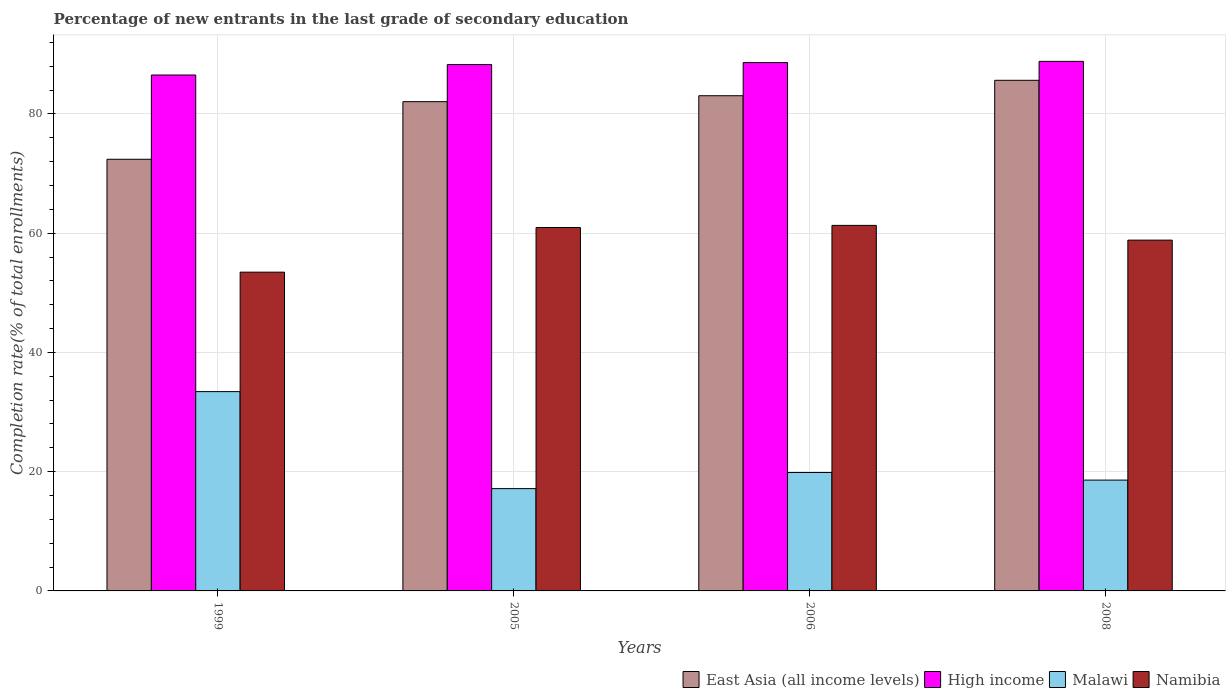How many groups of bars are there?
Provide a succinct answer. 4. How many bars are there on the 3rd tick from the left?
Offer a terse response. 4. How many bars are there on the 3rd tick from the right?
Give a very brief answer. 4. In how many cases, is the number of bars for a given year not equal to the number of legend labels?
Your response must be concise. 0. What is the percentage of new entrants in East Asia (all income levels) in 1999?
Offer a terse response. 72.4. Across all years, what is the maximum percentage of new entrants in Malawi?
Provide a short and direct response. 33.43. Across all years, what is the minimum percentage of new entrants in High income?
Give a very brief answer. 86.53. In which year was the percentage of new entrants in Namibia minimum?
Keep it short and to the point. 1999. What is the total percentage of new entrants in Malawi in the graph?
Offer a terse response. 89.04. What is the difference between the percentage of new entrants in High income in 2005 and that in 2008?
Provide a short and direct response. -0.54. What is the difference between the percentage of new entrants in High income in 2005 and the percentage of new entrants in Namibia in 2006?
Your response must be concise. 26.97. What is the average percentage of new entrants in Namibia per year?
Your answer should be very brief. 58.64. In the year 2005, what is the difference between the percentage of new entrants in Namibia and percentage of new entrants in East Asia (all income levels)?
Make the answer very short. -21.11. What is the ratio of the percentage of new entrants in Namibia in 2005 to that in 2008?
Your answer should be very brief. 1.04. Is the difference between the percentage of new entrants in Namibia in 1999 and 2006 greater than the difference between the percentage of new entrants in East Asia (all income levels) in 1999 and 2006?
Offer a very short reply. Yes. What is the difference between the highest and the second highest percentage of new entrants in East Asia (all income levels)?
Give a very brief answer. 2.59. What is the difference between the highest and the lowest percentage of new entrants in Namibia?
Offer a terse response. 7.85. In how many years, is the percentage of new entrants in High income greater than the average percentage of new entrants in High income taken over all years?
Your response must be concise. 3. Is it the case that in every year, the sum of the percentage of new entrants in High income and percentage of new entrants in East Asia (all income levels) is greater than the sum of percentage of new entrants in Malawi and percentage of new entrants in Namibia?
Give a very brief answer. Yes. What does the 2nd bar from the left in 2006 represents?
Make the answer very short. High income. What does the 2nd bar from the right in 2006 represents?
Give a very brief answer. Malawi. Is it the case that in every year, the sum of the percentage of new entrants in Namibia and percentage of new entrants in High income is greater than the percentage of new entrants in East Asia (all income levels)?
Your answer should be very brief. Yes. Are the values on the major ticks of Y-axis written in scientific E-notation?
Provide a short and direct response. No. Does the graph contain any zero values?
Provide a succinct answer. No. Does the graph contain grids?
Your answer should be compact. Yes. How are the legend labels stacked?
Your answer should be very brief. Horizontal. What is the title of the graph?
Make the answer very short. Percentage of new entrants in the last grade of secondary education. What is the label or title of the X-axis?
Provide a short and direct response. Years. What is the label or title of the Y-axis?
Make the answer very short. Completion rate(% of total enrollments). What is the Completion rate(% of total enrollments) in East Asia (all income levels) in 1999?
Ensure brevity in your answer.  72.4. What is the Completion rate(% of total enrollments) in High income in 1999?
Keep it short and to the point. 86.53. What is the Completion rate(% of total enrollments) of Malawi in 1999?
Keep it short and to the point. 33.43. What is the Completion rate(% of total enrollments) in Namibia in 1999?
Ensure brevity in your answer.  53.46. What is the Completion rate(% of total enrollments) of East Asia (all income levels) in 2005?
Keep it short and to the point. 82.06. What is the Completion rate(% of total enrollments) in High income in 2005?
Make the answer very short. 88.28. What is the Completion rate(% of total enrollments) of Malawi in 2005?
Keep it short and to the point. 17.16. What is the Completion rate(% of total enrollments) in Namibia in 2005?
Your answer should be compact. 60.95. What is the Completion rate(% of total enrollments) of East Asia (all income levels) in 2006?
Provide a short and direct response. 83.06. What is the Completion rate(% of total enrollments) in High income in 2006?
Offer a very short reply. 88.61. What is the Completion rate(% of total enrollments) of Malawi in 2006?
Give a very brief answer. 19.86. What is the Completion rate(% of total enrollments) in Namibia in 2006?
Your answer should be compact. 61.31. What is the Completion rate(% of total enrollments) of East Asia (all income levels) in 2008?
Provide a short and direct response. 85.64. What is the Completion rate(% of total enrollments) in High income in 2008?
Offer a very short reply. 88.82. What is the Completion rate(% of total enrollments) of Malawi in 2008?
Keep it short and to the point. 18.59. What is the Completion rate(% of total enrollments) in Namibia in 2008?
Your response must be concise. 58.84. Across all years, what is the maximum Completion rate(% of total enrollments) in East Asia (all income levels)?
Make the answer very short. 85.64. Across all years, what is the maximum Completion rate(% of total enrollments) in High income?
Offer a very short reply. 88.82. Across all years, what is the maximum Completion rate(% of total enrollments) of Malawi?
Your answer should be compact. 33.43. Across all years, what is the maximum Completion rate(% of total enrollments) of Namibia?
Offer a terse response. 61.31. Across all years, what is the minimum Completion rate(% of total enrollments) in East Asia (all income levels)?
Your answer should be compact. 72.4. Across all years, what is the minimum Completion rate(% of total enrollments) in High income?
Provide a succinct answer. 86.53. Across all years, what is the minimum Completion rate(% of total enrollments) of Malawi?
Ensure brevity in your answer.  17.16. Across all years, what is the minimum Completion rate(% of total enrollments) of Namibia?
Offer a very short reply. 53.46. What is the total Completion rate(% of total enrollments) of East Asia (all income levels) in the graph?
Your answer should be compact. 323.16. What is the total Completion rate(% of total enrollments) of High income in the graph?
Your answer should be very brief. 352.25. What is the total Completion rate(% of total enrollments) of Malawi in the graph?
Your response must be concise. 89.04. What is the total Completion rate(% of total enrollments) of Namibia in the graph?
Ensure brevity in your answer.  234.56. What is the difference between the Completion rate(% of total enrollments) in East Asia (all income levels) in 1999 and that in 2005?
Make the answer very short. -9.66. What is the difference between the Completion rate(% of total enrollments) in High income in 1999 and that in 2005?
Your response must be concise. -1.75. What is the difference between the Completion rate(% of total enrollments) in Malawi in 1999 and that in 2005?
Provide a short and direct response. 16.27. What is the difference between the Completion rate(% of total enrollments) in Namibia in 1999 and that in 2005?
Give a very brief answer. -7.49. What is the difference between the Completion rate(% of total enrollments) of East Asia (all income levels) in 1999 and that in 2006?
Your answer should be very brief. -10.66. What is the difference between the Completion rate(% of total enrollments) in High income in 1999 and that in 2006?
Offer a terse response. -2.08. What is the difference between the Completion rate(% of total enrollments) of Malawi in 1999 and that in 2006?
Provide a succinct answer. 13.56. What is the difference between the Completion rate(% of total enrollments) of Namibia in 1999 and that in 2006?
Your response must be concise. -7.85. What is the difference between the Completion rate(% of total enrollments) of East Asia (all income levels) in 1999 and that in 2008?
Make the answer very short. -13.25. What is the difference between the Completion rate(% of total enrollments) in High income in 1999 and that in 2008?
Offer a terse response. -2.29. What is the difference between the Completion rate(% of total enrollments) in Malawi in 1999 and that in 2008?
Make the answer very short. 14.84. What is the difference between the Completion rate(% of total enrollments) of Namibia in 1999 and that in 2008?
Your response must be concise. -5.37. What is the difference between the Completion rate(% of total enrollments) of East Asia (all income levels) in 2005 and that in 2006?
Give a very brief answer. -1. What is the difference between the Completion rate(% of total enrollments) of High income in 2005 and that in 2006?
Your answer should be very brief. -0.33. What is the difference between the Completion rate(% of total enrollments) of Malawi in 2005 and that in 2006?
Ensure brevity in your answer.  -2.71. What is the difference between the Completion rate(% of total enrollments) in Namibia in 2005 and that in 2006?
Ensure brevity in your answer.  -0.36. What is the difference between the Completion rate(% of total enrollments) of East Asia (all income levels) in 2005 and that in 2008?
Keep it short and to the point. -3.58. What is the difference between the Completion rate(% of total enrollments) of High income in 2005 and that in 2008?
Your response must be concise. -0.54. What is the difference between the Completion rate(% of total enrollments) in Malawi in 2005 and that in 2008?
Your answer should be very brief. -1.43. What is the difference between the Completion rate(% of total enrollments) in Namibia in 2005 and that in 2008?
Ensure brevity in your answer.  2.12. What is the difference between the Completion rate(% of total enrollments) of East Asia (all income levels) in 2006 and that in 2008?
Ensure brevity in your answer.  -2.59. What is the difference between the Completion rate(% of total enrollments) of High income in 2006 and that in 2008?
Your response must be concise. -0.21. What is the difference between the Completion rate(% of total enrollments) in Malawi in 2006 and that in 2008?
Provide a short and direct response. 1.28. What is the difference between the Completion rate(% of total enrollments) of Namibia in 2006 and that in 2008?
Provide a short and direct response. 2.47. What is the difference between the Completion rate(% of total enrollments) of East Asia (all income levels) in 1999 and the Completion rate(% of total enrollments) of High income in 2005?
Make the answer very short. -15.89. What is the difference between the Completion rate(% of total enrollments) of East Asia (all income levels) in 1999 and the Completion rate(% of total enrollments) of Malawi in 2005?
Keep it short and to the point. 55.24. What is the difference between the Completion rate(% of total enrollments) in East Asia (all income levels) in 1999 and the Completion rate(% of total enrollments) in Namibia in 2005?
Give a very brief answer. 11.44. What is the difference between the Completion rate(% of total enrollments) of High income in 1999 and the Completion rate(% of total enrollments) of Malawi in 2005?
Your answer should be compact. 69.37. What is the difference between the Completion rate(% of total enrollments) of High income in 1999 and the Completion rate(% of total enrollments) of Namibia in 2005?
Your answer should be very brief. 25.58. What is the difference between the Completion rate(% of total enrollments) of Malawi in 1999 and the Completion rate(% of total enrollments) of Namibia in 2005?
Ensure brevity in your answer.  -27.52. What is the difference between the Completion rate(% of total enrollments) in East Asia (all income levels) in 1999 and the Completion rate(% of total enrollments) in High income in 2006?
Make the answer very short. -16.21. What is the difference between the Completion rate(% of total enrollments) of East Asia (all income levels) in 1999 and the Completion rate(% of total enrollments) of Malawi in 2006?
Ensure brevity in your answer.  52.53. What is the difference between the Completion rate(% of total enrollments) of East Asia (all income levels) in 1999 and the Completion rate(% of total enrollments) of Namibia in 2006?
Ensure brevity in your answer.  11.09. What is the difference between the Completion rate(% of total enrollments) in High income in 1999 and the Completion rate(% of total enrollments) in Malawi in 2006?
Provide a succinct answer. 66.67. What is the difference between the Completion rate(% of total enrollments) in High income in 1999 and the Completion rate(% of total enrollments) in Namibia in 2006?
Your answer should be very brief. 25.22. What is the difference between the Completion rate(% of total enrollments) of Malawi in 1999 and the Completion rate(% of total enrollments) of Namibia in 2006?
Provide a succinct answer. -27.88. What is the difference between the Completion rate(% of total enrollments) in East Asia (all income levels) in 1999 and the Completion rate(% of total enrollments) in High income in 2008?
Keep it short and to the point. -16.42. What is the difference between the Completion rate(% of total enrollments) of East Asia (all income levels) in 1999 and the Completion rate(% of total enrollments) of Malawi in 2008?
Your response must be concise. 53.81. What is the difference between the Completion rate(% of total enrollments) of East Asia (all income levels) in 1999 and the Completion rate(% of total enrollments) of Namibia in 2008?
Make the answer very short. 13.56. What is the difference between the Completion rate(% of total enrollments) in High income in 1999 and the Completion rate(% of total enrollments) in Malawi in 2008?
Give a very brief answer. 67.94. What is the difference between the Completion rate(% of total enrollments) of High income in 1999 and the Completion rate(% of total enrollments) of Namibia in 2008?
Keep it short and to the point. 27.69. What is the difference between the Completion rate(% of total enrollments) in Malawi in 1999 and the Completion rate(% of total enrollments) in Namibia in 2008?
Ensure brevity in your answer.  -25.41. What is the difference between the Completion rate(% of total enrollments) in East Asia (all income levels) in 2005 and the Completion rate(% of total enrollments) in High income in 2006?
Provide a succinct answer. -6.55. What is the difference between the Completion rate(% of total enrollments) of East Asia (all income levels) in 2005 and the Completion rate(% of total enrollments) of Malawi in 2006?
Provide a short and direct response. 62.2. What is the difference between the Completion rate(% of total enrollments) of East Asia (all income levels) in 2005 and the Completion rate(% of total enrollments) of Namibia in 2006?
Offer a terse response. 20.75. What is the difference between the Completion rate(% of total enrollments) in High income in 2005 and the Completion rate(% of total enrollments) in Malawi in 2006?
Offer a very short reply. 68.42. What is the difference between the Completion rate(% of total enrollments) of High income in 2005 and the Completion rate(% of total enrollments) of Namibia in 2006?
Ensure brevity in your answer.  26.97. What is the difference between the Completion rate(% of total enrollments) in Malawi in 2005 and the Completion rate(% of total enrollments) in Namibia in 2006?
Make the answer very short. -44.15. What is the difference between the Completion rate(% of total enrollments) in East Asia (all income levels) in 2005 and the Completion rate(% of total enrollments) in High income in 2008?
Make the answer very short. -6.76. What is the difference between the Completion rate(% of total enrollments) of East Asia (all income levels) in 2005 and the Completion rate(% of total enrollments) of Malawi in 2008?
Give a very brief answer. 63.47. What is the difference between the Completion rate(% of total enrollments) in East Asia (all income levels) in 2005 and the Completion rate(% of total enrollments) in Namibia in 2008?
Offer a terse response. 23.22. What is the difference between the Completion rate(% of total enrollments) of High income in 2005 and the Completion rate(% of total enrollments) of Malawi in 2008?
Keep it short and to the point. 69.7. What is the difference between the Completion rate(% of total enrollments) in High income in 2005 and the Completion rate(% of total enrollments) in Namibia in 2008?
Provide a short and direct response. 29.45. What is the difference between the Completion rate(% of total enrollments) of Malawi in 2005 and the Completion rate(% of total enrollments) of Namibia in 2008?
Keep it short and to the point. -41.68. What is the difference between the Completion rate(% of total enrollments) of East Asia (all income levels) in 2006 and the Completion rate(% of total enrollments) of High income in 2008?
Provide a short and direct response. -5.77. What is the difference between the Completion rate(% of total enrollments) in East Asia (all income levels) in 2006 and the Completion rate(% of total enrollments) in Malawi in 2008?
Your answer should be compact. 64.47. What is the difference between the Completion rate(% of total enrollments) in East Asia (all income levels) in 2006 and the Completion rate(% of total enrollments) in Namibia in 2008?
Keep it short and to the point. 24.22. What is the difference between the Completion rate(% of total enrollments) of High income in 2006 and the Completion rate(% of total enrollments) of Malawi in 2008?
Give a very brief answer. 70.02. What is the difference between the Completion rate(% of total enrollments) in High income in 2006 and the Completion rate(% of total enrollments) in Namibia in 2008?
Your answer should be compact. 29.77. What is the difference between the Completion rate(% of total enrollments) in Malawi in 2006 and the Completion rate(% of total enrollments) in Namibia in 2008?
Offer a very short reply. -38.97. What is the average Completion rate(% of total enrollments) in East Asia (all income levels) per year?
Give a very brief answer. 80.79. What is the average Completion rate(% of total enrollments) in High income per year?
Provide a short and direct response. 88.06. What is the average Completion rate(% of total enrollments) of Malawi per year?
Provide a short and direct response. 22.26. What is the average Completion rate(% of total enrollments) in Namibia per year?
Ensure brevity in your answer.  58.64. In the year 1999, what is the difference between the Completion rate(% of total enrollments) in East Asia (all income levels) and Completion rate(% of total enrollments) in High income?
Your response must be concise. -14.13. In the year 1999, what is the difference between the Completion rate(% of total enrollments) of East Asia (all income levels) and Completion rate(% of total enrollments) of Malawi?
Provide a short and direct response. 38.97. In the year 1999, what is the difference between the Completion rate(% of total enrollments) in East Asia (all income levels) and Completion rate(% of total enrollments) in Namibia?
Keep it short and to the point. 18.93. In the year 1999, what is the difference between the Completion rate(% of total enrollments) in High income and Completion rate(% of total enrollments) in Malawi?
Provide a succinct answer. 53.1. In the year 1999, what is the difference between the Completion rate(% of total enrollments) in High income and Completion rate(% of total enrollments) in Namibia?
Your answer should be very brief. 33.07. In the year 1999, what is the difference between the Completion rate(% of total enrollments) in Malawi and Completion rate(% of total enrollments) in Namibia?
Your answer should be very brief. -20.04. In the year 2005, what is the difference between the Completion rate(% of total enrollments) of East Asia (all income levels) and Completion rate(% of total enrollments) of High income?
Your answer should be compact. -6.22. In the year 2005, what is the difference between the Completion rate(% of total enrollments) in East Asia (all income levels) and Completion rate(% of total enrollments) in Malawi?
Offer a terse response. 64.9. In the year 2005, what is the difference between the Completion rate(% of total enrollments) of East Asia (all income levels) and Completion rate(% of total enrollments) of Namibia?
Your answer should be compact. 21.11. In the year 2005, what is the difference between the Completion rate(% of total enrollments) in High income and Completion rate(% of total enrollments) in Malawi?
Ensure brevity in your answer.  71.12. In the year 2005, what is the difference between the Completion rate(% of total enrollments) of High income and Completion rate(% of total enrollments) of Namibia?
Your response must be concise. 27.33. In the year 2005, what is the difference between the Completion rate(% of total enrollments) of Malawi and Completion rate(% of total enrollments) of Namibia?
Give a very brief answer. -43.79. In the year 2006, what is the difference between the Completion rate(% of total enrollments) of East Asia (all income levels) and Completion rate(% of total enrollments) of High income?
Offer a very short reply. -5.56. In the year 2006, what is the difference between the Completion rate(% of total enrollments) in East Asia (all income levels) and Completion rate(% of total enrollments) in Malawi?
Give a very brief answer. 63.19. In the year 2006, what is the difference between the Completion rate(% of total enrollments) in East Asia (all income levels) and Completion rate(% of total enrollments) in Namibia?
Your response must be concise. 21.75. In the year 2006, what is the difference between the Completion rate(% of total enrollments) in High income and Completion rate(% of total enrollments) in Malawi?
Make the answer very short. 68.75. In the year 2006, what is the difference between the Completion rate(% of total enrollments) of High income and Completion rate(% of total enrollments) of Namibia?
Your answer should be very brief. 27.3. In the year 2006, what is the difference between the Completion rate(% of total enrollments) in Malawi and Completion rate(% of total enrollments) in Namibia?
Provide a short and direct response. -41.45. In the year 2008, what is the difference between the Completion rate(% of total enrollments) in East Asia (all income levels) and Completion rate(% of total enrollments) in High income?
Offer a very short reply. -3.18. In the year 2008, what is the difference between the Completion rate(% of total enrollments) of East Asia (all income levels) and Completion rate(% of total enrollments) of Malawi?
Ensure brevity in your answer.  67.06. In the year 2008, what is the difference between the Completion rate(% of total enrollments) in East Asia (all income levels) and Completion rate(% of total enrollments) in Namibia?
Give a very brief answer. 26.81. In the year 2008, what is the difference between the Completion rate(% of total enrollments) in High income and Completion rate(% of total enrollments) in Malawi?
Offer a very short reply. 70.23. In the year 2008, what is the difference between the Completion rate(% of total enrollments) of High income and Completion rate(% of total enrollments) of Namibia?
Offer a very short reply. 29.98. In the year 2008, what is the difference between the Completion rate(% of total enrollments) in Malawi and Completion rate(% of total enrollments) in Namibia?
Your answer should be very brief. -40.25. What is the ratio of the Completion rate(% of total enrollments) of East Asia (all income levels) in 1999 to that in 2005?
Offer a very short reply. 0.88. What is the ratio of the Completion rate(% of total enrollments) of High income in 1999 to that in 2005?
Provide a succinct answer. 0.98. What is the ratio of the Completion rate(% of total enrollments) in Malawi in 1999 to that in 2005?
Provide a short and direct response. 1.95. What is the ratio of the Completion rate(% of total enrollments) of Namibia in 1999 to that in 2005?
Your answer should be compact. 0.88. What is the ratio of the Completion rate(% of total enrollments) of East Asia (all income levels) in 1999 to that in 2006?
Keep it short and to the point. 0.87. What is the ratio of the Completion rate(% of total enrollments) in High income in 1999 to that in 2006?
Ensure brevity in your answer.  0.98. What is the ratio of the Completion rate(% of total enrollments) of Malawi in 1999 to that in 2006?
Provide a succinct answer. 1.68. What is the ratio of the Completion rate(% of total enrollments) in Namibia in 1999 to that in 2006?
Offer a very short reply. 0.87. What is the ratio of the Completion rate(% of total enrollments) in East Asia (all income levels) in 1999 to that in 2008?
Ensure brevity in your answer.  0.85. What is the ratio of the Completion rate(% of total enrollments) of High income in 1999 to that in 2008?
Give a very brief answer. 0.97. What is the ratio of the Completion rate(% of total enrollments) in Malawi in 1999 to that in 2008?
Provide a succinct answer. 1.8. What is the ratio of the Completion rate(% of total enrollments) of Namibia in 1999 to that in 2008?
Keep it short and to the point. 0.91. What is the ratio of the Completion rate(% of total enrollments) of East Asia (all income levels) in 2005 to that in 2006?
Your response must be concise. 0.99. What is the ratio of the Completion rate(% of total enrollments) in Malawi in 2005 to that in 2006?
Make the answer very short. 0.86. What is the ratio of the Completion rate(% of total enrollments) in Namibia in 2005 to that in 2006?
Offer a terse response. 0.99. What is the ratio of the Completion rate(% of total enrollments) in East Asia (all income levels) in 2005 to that in 2008?
Your answer should be very brief. 0.96. What is the ratio of the Completion rate(% of total enrollments) in High income in 2005 to that in 2008?
Ensure brevity in your answer.  0.99. What is the ratio of the Completion rate(% of total enrollments) in Malawi in 2005 to that in 2008?
Provide a succinct answer. 0.92. What is the ratio of the Completion rate(% of total enrollments) of Namibia in 2005 to that in 2008?
Ensure brevity in your answer.  1.04. What is the ratio of the Completion rate(% of total enrollments) of East Asia (all income levels) in 2006 to that in 2008?
Offer a very short reply. 0.97. What is the ratio of the Completion rate(% of total enrollments) of High income in 2006 to that in 2008?
Make the answer very short. 1. What is the ratio of the Completion rate(% of total enrollments) in Malawi in 2006 to that in 2008?
Your response must be concise. 1.07. What is the ratio of the Completion rate(% of total enrollments) in Namibia in 2006 to that in 2008?
Provide a short and direct response. 1.04. What is the difference between the highest and the second highest Completion rate(% of total enrollments) in East Asia (all income levels)?
Your answer should be compact. 2.59. What is the difference between the highest and the second highest Completion rate(% of total enrollments) of High income?
Your answer should be very brief. 0.21. What is the difference between the highest and the second highest Completion rate(% of total enrollments) in Malawi?
Offer a terse response. 13.56. What is the difference between the highest and the second highest Completion rate(% of total enrollments) in Namibia?
Your answer should be very brief. 0.36. What is the difference between the highest and the lowest Completion rate(% of total enrollments) in East Asia (all income levels)?
Your answer should be compact. 13.25. What is the difference between the highest and the lowest Completion rate(% of total enrollments) in High income?
Provide a short and direct response. 2.29. What is the difference between the highest and the lowest Completion rate(% of total enrollments) in Malawi?
Offer a very short reply. 16.27. What is the difference between the highest and the lowest Completion rate(% of total enrollments) of Namibia?
Give a very brief answer. 7.85. 